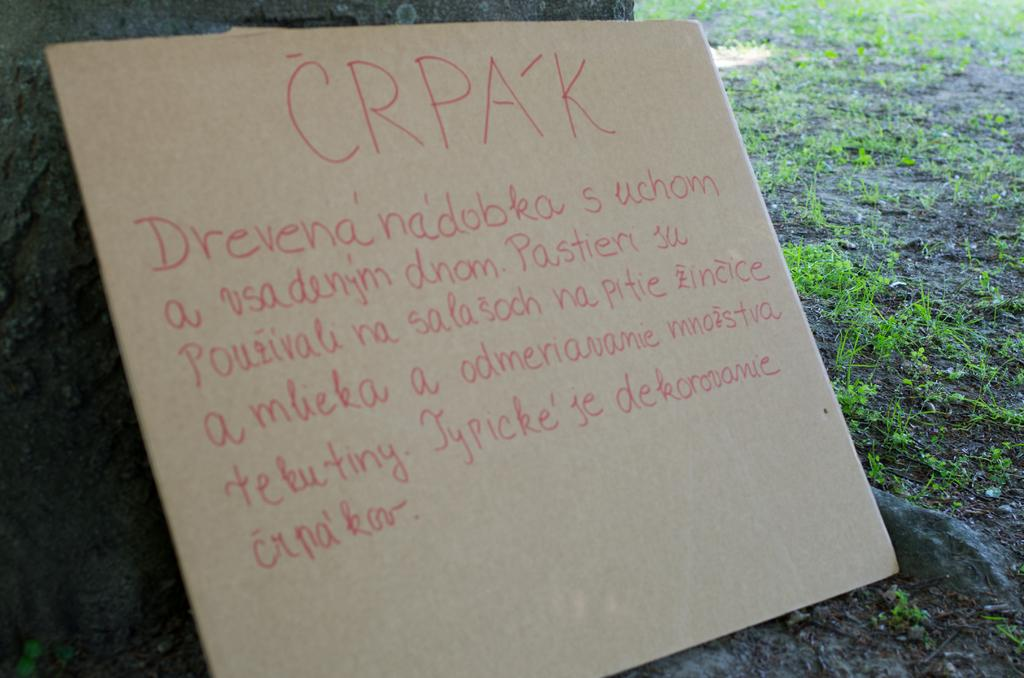What is the main object in the image? There is a board with text in the image. What can be seen on the board? The text is written on the board. What type of surface is visible in the background of the image? There is grass on the ground in the background of the image. What color is the heart that is hidden in the grass in the image? There is no heart present in the image, and therefore no such hidden object can be observed. 